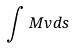Convert formula to latex. <formula><loc_0><loc_0><loc_500><loc_500>\int M v d s</formula> 